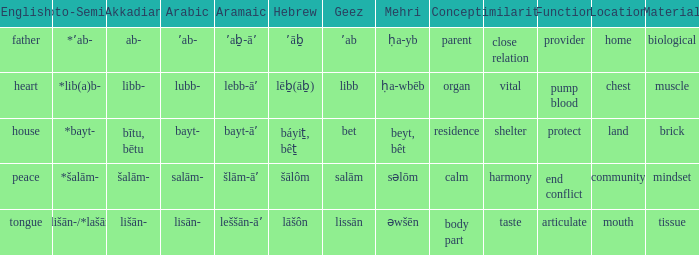If the geez language is libb, what would be the akkadian language? Libb-. 